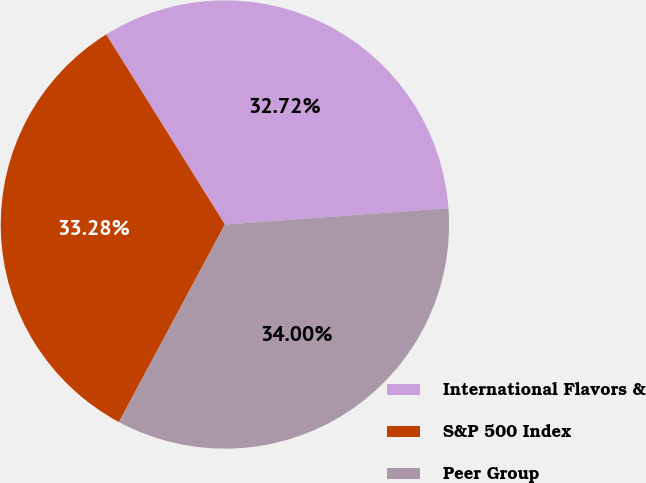Convert chart to OTSL. <chart><loc_0><loc_0><loc_500><loc_500><pie_chart><fcel>International Flavors &<fcel>S&P 500 Index<fcel>Peer Group<nl><fcel>32.72%<fcel>33.28%<fcel>34.0%<nl></chart> 